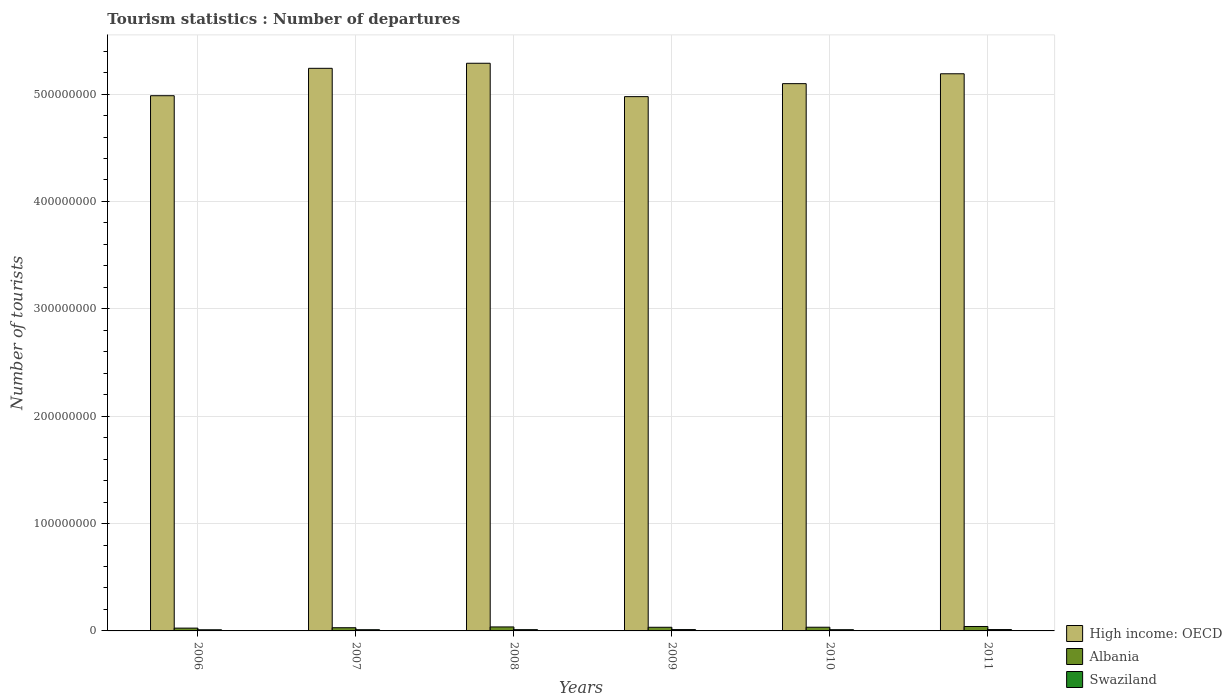Are the number of bars per tick equal to the number of legend labels?
Offer a very short reply. Yes. How many bars are there on the 3rd tick from the left?
Provide a succinct answer. 3. How many bars are there on the 2nd tick from the right?
Provide a short and direct response. 3. What is the number of tourist departures in Albania in 2011?
Ensure brevity in your answer.  4.12e+06. Across all years, what is the maximum number of tourist departures in Swaziland?
Provide a succinct answer. 1.26e+06. Across all years, what is the minimum number of tourist departures in Swaziland?
Offer a very short reply. 1.07e+06. In which year was the number of tourist departures in High income: OECD maximum?
Ensure brevity in your answer.  2008. What is the total number of tourist departures in Albania in the graph?
Give a very brief answer. 2.03e+07. What is the difference between the number of tourist departures in Swaziland in 2009 and that in 2011?
Offer a very short reply. -1.90e+04. What is the difference between the number of tourist departures in High income: OECD in 2007 and the number of tourist departures in Swaziland in 2010?
Your answer should be very brief. 5.23e+08. What is the average number of tourist departures in Albania per year?
Provide a succinct answer. 3.38e+06. In the year 2011, what is the difference between the number of tourist departures in Swaziland and number of tourist departures in Albania?
Offer a very short reply. -2.86e+06. What is the ratio of the number of tourist departures in High income: OECD in 2008 to that in 2010?
Your answer should be very brief. 1.04. Is the number of tourist departures in High income: OECD in 2009 less than that in 2010?
Ensure brevity in your answer.  Yes. Is the difference between the number of tourist departures in Swaziland in 2007 and 2009 greater than the difference between the number of tourist departures in Albania in 2007 and 2009?
Your response must be concise. Yes. What is the difference between the highest and the second highest number of tourist departures in Swaziland?
Offer a terse response. 1.90e+04. What is the difference between the highest and the lowest number of tourist departures in Swaziland?
Offer a very short reply. 1.92e+05. In how many years, is the number of tourist departures in High income: OECD greater than the average number of tourist departures in High income: OECD taken over all years?
Your answer should be compact. 3. Is the sum of the number of tourist departures in Albania in 2007 and 2010 greater than the maximum number of tourist departures in High income: OECD across all years?
Your answer should be compact. No. What does the 2nd bar from the left in 2006 represents?
Provide a short and direct response. Albania. What does the 2nd bar from the right in 2007 represents?
Your response must be concise. Albania. How many bars are there?
Offer a very short reply. 18. Are all the bars in the graph horizontal?
Make the answer very short. No. What is the difference between two consecutive major ticks on the Y-axis?
Provide a short and direct response. 1.00e+08. Does the graph contain any zero values?
Offer a very short reply. No. How many legend labels are there?
Ensure brevity in your answer.  3. How are the legend labels stacked?
Offer a terse response. Vertical. What is the title of the graph?
Provide a succinct answer. Tourism statistics : Number of departures. What is the label or title of the X-axis?
Make the answer very short. Years. What is the label or title of the Y-axis?
Your answer should be very brief. Number of tourists. What is the Number of tourists of High income: OECD in 2006?
Ensure brevity in your answer.  4.98e+08. What is the Number of tourists of Albania in 2006?
Your response must be concise. 2.62e+06. What is the Number of tourists of Swaziland in 2006?
Ensure brevity in your answer.  1.07e+06. What is the Number of tourists in High income: OECD in 2007?
Offer a terse response. 5.24e+08. What is the Number of tourists in Albania in 2007?
Make the answer very short. 2.98e+06. What is the Number of tourists in Swaziland in 2007?
Your answer should be compact. 1.13e+06. What is the Number of tourists in High income: OECD in 2008?
Offer a very short reply. 5.29e+08. What is the Number of tourists in Albania in 2008?
Ensure brevity in your answer.  3.72e+06. What is the Number of tourists in Swaziland in 2008?
Provide a succinct answer. 1.18e+06. What is the Number of tourists in High income: OECD in 2009?
Give a very brief answer. 4.98e+08. What is the Number of tourists of Albania in 2009?
Your answer should be compact. 3.40e+06. What is the Number of tourists of Swaziland in 2009?
Make the answer very short. 1.24e+06. What is the Number of tourists in High income: OECD in 2010?
Make the answer very short. 5.10e+08. What is the Number of tourists in Albania in 2010?
Give a very brief answer. 3.44e+06. What is the Number of tourists of Swaziland in 2010?
Your answer should be very brief. 1.14e+06. What is the Number of tourists in High income: OECD in 2011?
Your answer should be very brief. 5.19e+08. What is the Number of tourists in Albania in 2011?
Provide a short and direct response. 4.12e+06. What is the Number of tourists in Swaziland in 2011?
Offer a terse response. 1.26e+06. Across all years, what is the maximum Number of tourists in High income: OECD?
Make the answer very short. 5.29e+08. Across all years, what is the maximum Number of tourists in Albania?
Your answer should be compact. 4.12e+06. Across all years, what is the maximum Number of tourists in Swaziland?
Provide a short and direct response. 1.26e+06. Across all years, what is the minimum Number of tourists of High income: OECD?
Offer a terse response. 4.98e+08. Across all years, what is the minimum Number of tourists in Albania?
Make the answer very short. 2.62e+06. Across all years, what is the minimum Number of tourists in Swaziland?
Offer a very short reply. 1.07e+06. What is the total Number of tourists in High income: OECD in the graph?
Make the answer very short. 3.08e+09. What is the total Number of tourists in Albania in the graph?
Ensure brevity in your answer.  2.03e+07. What is the total Number of tourists of Swaziland in the graph?
Provide a succinct answer. 7.03e+06. What is the difference between the Number of tourists of High income: OECD in 2006 and that in 2007?
Give a very brief answer. -2.55e+07. What is the difference between the Number of tourists in Albania in 2006 and that in 2007?
Your response must be concise. -3.63e+05. What is the difference between the Number of tourists in Swaziland in 2006 and that in 2007?
Give a very brief answer. -5.80e+04. What is the difference between the Number of tourists of High income: OECD in 2006 and that in 2008?
Your response must be concise. -3.02e+07. What is the difference between the Number of tourists in Albania in 2006 and that in 2008?
Offer a very short reply. -1.10e+06. What is the difference between the Number of tourists in Swaziland in 2006 and that in 2008?
Offer a terse response. -1.05e+05. What is the difference between the Number of tourists of High income: OECD in 2006 and that in 2009?
Offer a terse response. 8.58e+05. What is the difference between the Number of tourists in Albania in 2006 and that in 2009?
Provide a short and direct response. -7.88e+05. What is the difference between the Number of tourists of Swaziland in 2006 and that in 2009?
Provide a succinct answer. -1.73e+05. What is the difference between the Number of tourists of High income: OECD in 2006 and that in 2010?
Give a very brief answer. -1.12e+07. What is the difference between the Number of tourists of Albania in 2006 and that in 2010?
Offer a very short reply. -8.27e+05. What is the difference between the Number of tourists of Swaziland in 2006 and that in 2010?
Your answer should be very brief. -6.90e+04. What is the difference between the Number of tourists in High income: OECD in 2006 and that in 2011?
Offer a terse response. -2.04e+07. What is the difference between the Number of tourists in Albania in 2006 and that in 2011?
Your answer should be compact. -1.50e+06. What is the difference between the Number of tourists of Swaziland in 2006 and that in 2011?
Give a very brief answer. -1.92e+05. What is the difference between the Number of tourists in High income: OECD in 2007 and that in 2008?
Provide a succinct answer. -4.72e+06. What is the difference between the Number of tourists in Albania in 2007 and that in 2008?
Give a very brief answer. -7.37e+05. What is the difference between the Number of tourists of Swaziland in 2007 and that in 2008?
Your answer should be compact. -4.70e+04. What is the difference between the Number of tourists of High income: OECD in 2007 and that in 2009?
Your answer should be very brief. 2.64e+07. What is the difference between the Number of tourists in Albania in 2007 and that in 2009?
Provide a succinct answer. -4.25e+05. What is the difference between the Number of tourists of Swaziland in 2007 and that in 2009?
Provide a short and direct response. -1.15e+05. What is the difference between the Number of tourists of High income: OECD in 2007 and that in 2010?
Provide a succinct answer. 1.43e+07. What is the difference between the Number of tourists of Albania in 2007 and that in 2010?
Your response must be concise. -4.64e+05. What is the difference between the Number of tourists of Swaziland in 2007 and that in 2010?
Your answer should be very brief. -1.10e+04. What is the difference between the Number of tourists in High income: OECD in 2007 and that in 2011?
Make the answer very short. 5.07e+06. What is the difference between the Number of tourists of Albania in 2007 and that in 2011?
Keep it short and to the point. -1.14e+06. What is the difference between the Number of tourists of Swaziland in 2007 and that in 2011?
Your answer should be very brief. -1.34e+05. What is the difference between the Number of tourists of High income: OECD in 2008 and that in 2009?
Your answer should be very brief. 3.11e+07. What is the difference between the Number of tourists of Albania in 2008 and that in 2009?
Keep it short and to the point. 3.12e+05. What is the difference between the Number of tourists in Swaziland in 2008 and that in 2009?
Make the answer very short. -6.80e+04. What is the difference between the Number of tourists in High income: OECD in 2008 and that in 2010?
Your answer should be very brief. 1.90e+07. What is the difference between the Number of tourists in Albania in 2008 and that in 2010?
Keep it short and to the point. 2.73e+05. What is the difference between the Number of tourists of Swaziland in 2008 and that in 2010?
Give a very brief answer. 3.60e+04. What is the difference between the Number of tourists in High income: OECD in 2008 and that in 2011?
Ensure brevity in your answer.  9.79e+06. What is the difference between the Number of tourists of Albania in 2008 and that in 2011?
Make the answer very short. -4.04e+05. What is the difference between the Number of tourists in Swaziland in 2008 and that in 2011?
Offer a very short reply. -8.70e+04. What is the difference between the Number of tourists in High income: OECD in 2009 and that in 2010?
Offer a very short reply. -1.21e+07. What is the difference between the Number of tourists of Albania in 2009 and that in 2010?
Provide a succinct answer. -3.90e+04. What is the difference between the Number of tourists in Swaziland in 2009 and that in 2010?
Offer a terse response. 1.04e+05. What is the difference between the Number of tourists of High income: OECD in 2009 and that in 2011?
Provide a succinct answer. -2.13e+07. What is the difference between the Number of tourists in Albania in 2009 and that in 2011?
Offer a terse response. -7.16e+05. What is the difference between the Number of tourists in Swaziland in 2009 and that in 2011?
Keep it short and to the point. -1.90e+04. What is the difference between the Number of tourists of High income: OECD in 2010 and that in 2011?
Give a very brief answer. -9.20e+06. What is the difference between the Number of tourists in Albania in 2010 and that in 2011?
Make the answer very short. -6.77e+05. What is the difference between the Number of tourists in Swaziland in 2010 and that in 2011?
Your answer should be very brief. -1.23e+05. What is the difference between the Number of tourists of High income: OECD in 2006 and the Number of tourists of Albania in 2007?
Provide a succinct answer. 4.95e+08. What is the difference between the Number of tourists of High income: OECD in 2006 and the Number of tourists of Swaziland in 2007?
Ensure brevity in your answer.  4.97e+08. What is the difference between the Number of tourists of Albania in 2006 and the Number of tourists of Swaziland in 2007?
Ensure brevity in your answer.  1.49e+06. What is the difference between the Number of tourists in High income: OECD in 2006 and the Number of tourists in Albania in 2008?
Make the answer very short. 4.95e+08. What is the difference between the Number of tourists of High income: OECD in 2006 and the Number of tourists of Swaziland in 2008?
Make the answer very short. 4.97e+08. What is the difference between the Number of tourists of Albania in 2006 and the Number of tourists of Swaziland in 2008?
Provide a succinct answer. 1.44e+06. What is the difference between the Number of tourists in High income: OECD in 2006 and the Number of tourists in Albania in 2009?
Provide a succinct answer. 4.95e+08. What is the difference between the Number of tourists in High income: OECD in 2006 and the Number of tourists in Swaziland in 2009?
Give a very brief answer. 4.97e+08. What is the difference between the Number of tourists in Albania in 2006 and the Number of tourists in Swaziland in 2009?
Your answer should be very brief. 1.37e+06. What is the difference between the Number of tourists in High income: OECD in 2006 and the Number of tourists in Albania in 2010?
Give a very brief answer. 4.95e+08. What is the difference between the Number of tourists of High income: OECD in 2006 and the Number of tourists of Swaziland in 2010?
Ensure brevity in your answer.  4.97e+08. What is the difference between the Number of tourists in Albania in 2006 and the Number of tourists in Swaziland in 2010?
Keep it short and to the point. 1.48e+06. What is the difference between the Number of tourists of High income: OECD in 2006 and the Number of tourists of Albania in 2011?
Keep it short and to the point. 4.94e+08. What is the difference between the Number of tourists of High income: OECD in 2006 and the Number of tourists of Swaziland in 2011?
Ensure brevity in your answer.  4.97e+08. What is the difference between the Number of tourists of Albania in 2006 and the Number of tourists of Swaziland in 2011?
Keep it short and to the point. 1.35e+06. What is the difference between the Number of tourists in High income: OECD in 2007 and the Number of tourists in Albania in 2008?
Offer a very short reply. 5.20e+08. What is the difference between the Number of tourists of High income: OECD in 2007 and the Number of tourists of Swaziland in 2008?
Offer a terse response. 5.23e+08. What is the difference between the Number of tourists of Albania in 2007 and the Number of tourists of Swaziland in 2008?
Your answer should be very brief. 1.80e+06. What is the difference between the Number of tourists in High income: OECD in 2007 and the Number of tourists in Albania in 2009?
Make the answer very short. 5.21e+08. What is the difference between the Number of tourists of High income: OECD in 2007 and the Number of tourists of Swaziland in 2009?
Offer a terse response. 5.23e+08. What is the difference between the Number of tourists of Albania in 2007 and the Number of tourists of Swaziland in 2009?
Your answer should be very brief. 1.73e+06. What is the difference between the Number of tourists of High income: OECD in 2007 and the Number of tourists of Albania in 2010?
Ensure brevity in your answer.  5.21e+08. What is the difference between the Number of tourists of High income: OECD in 2007 and the Number of tourists of Swaziland in 2010?
Ensure brevity in your answer.  5.23e+08. What is the difference between the Number of tourists of Albania in 2007 and the Number of tourists of Swaziland in 2010?
Make the answer very short. 1.84e+06. What is the difference between the Number of tourists of High income: OECD in 2007 and the Number of tourists of Albania in 2011?
Provide a succinct answer. 5.20e+08. What is the difference between the Number of tourists in High income: OECD in 2007 and the Number of tourists in Swaziland in 2011?
Your response must be concise. 5.23e+08. What is the difference between the Number of tourists in Albania in 2007 and the Number of tourists in Swaziland in 2011?
Make the answer very short. 1.72e+06. What is the difference between the Number of tourists of High income: OECD in 2008 and the Number of tourists of Albania in 2009?
Offer a terse response. 5.25e+08. What is the difference between the Number of tourists of High income: OECD in 2008 and the Number of tourists of Swaziland in 2009?
Provide a short and direct response. 5.27e+08. What is the difference between the Number of tourists of Albania in 2008 and the Number of tourists of Swaziland in 2009?
Keep it short and to the point. 2.47e+06. What is the difference between the Number of tourists of High income: OECD in 2008 and the Number of tourists of Albania in 2010?
Ensure brevity in your answer.  5.25e+08. What is the difference between the Number of tourists in High income: OECD in 2008 and the Number of tourists in Swaziland in 2010?
Offer a terse response. 5.28e+08. What is the difference between the Number of tourists in Albania in 2008 and the Number of tourists in Swaziland in 2010?
Offer a very short reply. 2.58e+06. What is the difference between the Number of tourists in High income: OECD in 2008 and the Number of tourists in Albania in 2011?
Offer a very short reply. 5.25e+08. What is the difference between the Number of tourists of High income: OECD in 2008 and the Number of tourists of Swaziland in 2011?
Make the answer very short. 5.27e+08. What is the difference between the Number of tourists of Albania in 2008 and the Number of tourists of Swaziland in 2011?
Your answer should be compact. 2.45e+06. What is the difference between the Number of tourists of High income: OECD in 2009 and the Number of tourists of Albania in 2010?
Your answer should be very brief. 4.94e+08. What is the difference between the Number of tourists in High income: OECD in 2009 and the Number of tourists in Swaziland in 2010?
Provide a succinct answer. 4.96e+08. What is the difference between the Number of tourists of Albania in 2009 and the Number of tourists of Swaziland in 2010?
Your answer should be compact. 2.26e+06. What is the difference between the Number of tourists of High income: OECD in 2009 and the Number of tourists of Albania in 2011?
Offer a terse response. 4.93e+08. What is the difference between the Number of tourists of High income: OECD in 2009 and the Number of tourists of Swaziland in 2011?
Give a very brief answer. 4.96e+08. What is the difference between the Number of tourists in Albania in 2009 and the Number of tourists in Swaziland in 2011?
Ensure brevity in your answer.  2.14e+06. What is the difference between the Number of tourists in High income: OECD in 2010 and the Number of tourists in Albania in 2011?
Your answer should be compact. 5.06e+08. What is the difference between the Number of tourists in High income: OECD in 2010 and the Number of tourists in Swaziland in 2011?
Offer a terse response. 5.08e+08. What is the difference between the Number of tourists in Albania in 2010 and the Number of tourists in Swaziland in 2011?
Provide a succinct answer. 2.18e+06. What is the average Number of tourists in High income: OECD per year?
Provide a succinct answer. 5.13e+08. What is the average Number of tourists in Albania per year?
Your answer should be very brief. 3.38e+06. What is the average Number of tourists of Swaziland per year?
Your response must be concise. 1.17e+06. In the year 2006, what is the difference between the Number of tourists of High income: OECD and Number of tourists of Albania?
Provide a short and direct response. 4.96e+08. In the year 2006, what is the difference between the Number of tourists of High income: OECD and Number of tourists of Swaziland?
Make the answer very short. 4.97e+08. In the year 2006, what is the difference between the Number of tourists in Albania and Number of tourists in Swaziland?
Make the answer very short. 1.54e+06. In the year 2007, what is the difference between the Number of tourists of High income: OECD and Number of tourists of Albania?
Offer a terse response. 5.21e+08. In the year 2007, what is the difference between the Number of tourists of High income: OECD and Number of tourists of Swaziland?
Ensure brevity in your answer.  5.23e+08. In the year 2007, what is the difference between the Number of tourists of Albania and Number of tourists of Swaziland?
Make the answer very short. 1.85e+06. In the year 2008, what is the difference between the Number of tourists in High income: OECD and Number of tourists in Albania?
Make the answer very short. 5.25e+08. In the year 2008, what is the difference between the Number of tourists in High income: OECD and Number of tourists in Swaziland?
Your response must be concise. 5.28e+08. In the year 2008, what is the difference between the Number of tourists in Albania and Number of tourists in Swaziland?
Keep it short and to the point. 2.54e+06. In the year 2009, what is the difference between the Number of tourists of High income: OECD and Number of tourists of Albania?
Provide a succinct answer. 4.94e+08. In the year 2009, what is the difference between the Number of tourists of High income: OECD and Number of tourists of Swaziland?
Give a very brief answer. 4.96e+08. In the year 2009, what is the difference between the Number of tourists in Albania and Number of tourists in Swaziland?
Keep it short and to the point. 2.16e+06. In the year 2010, what is the difference between the Number of tourists in High income: OECD and Number of tourists in Albania?
Make the answer very short. 5.06e+08. In the year 2010, what is the difference between the Number of tourists in High income: OECD and Number of tourists in Swaziland?
Ensure brevity in your answer.  5.09e+08. In the year 2010, what is the difference between the Number of tourists in Albania and Number of tourists in Swaziland?
Ensure brevity in your answer.  2.30e+06. In the year 2011, what is the difference between the Number of tourists in High income: OECD and Number of tourists in Albania?
Offer a very short reply. 5.15e+08. In the year 2011, what is the difference between the Number of tourists of High income: OECD and Number of tourists of Swaziland?
Provide a short and direct response. 5.18e+08. In the year 2011, what is the difference between the Number of tourists in Albania and Number of tourists in Swaziland?
Your response must be concise. 2.86e+06. What is the ratio of the Number of tourists in High income: OECD in 2006 to that in 2007?
Your answer should be very brief. 0.95. What is the ratio of the Number of tourists of Albania in 2006 to that in 2007?
Offer a very short reply. 0.88. What is the ratio of the Number of tourists in Swaziland in 2006 to that in 2007?
Your response must be concise. 0.95. What is the ratio of the Number of tourists in High income: OECD in 2006 to that in 2008?
Keep it short and to the point. 0.94. What is the ratio of the Number of tourists of Albania in 2006 to that in 2008?
Keep it short and to the point. 0.7. What is the ratio of the Number of tourists in Swaziland in 2006 to that in 2008?
Ensure brevity in your answer.  0.91. What is the ratio of the Number of tourists in High income: OECD in 2006 to that in 2009?
Your response must be concise. 1. What is the ratio of the Number of tourists in Albania in 2006 to that in 2009?
Your answer should be very brief. 0.77. What is the ratio of the Number of tourists of Swaziland in 2006 to that in 2009?
Provide a succinct answer. 0.86. What is the ratio of the Number of tourists in Albania in 2006 to that in 2010?
Provide a succinct answer. 0.76. What is the ratio of the Number of tourists of Swaziland in 2006 to that in 2010?
Keep it short and to the point. 0.94. What is the ratio of the Number of tourists in High income: OECD in 2006 to that in 2011?
Offer a terse response. 0.96. What is the ratio of the Number of tourists of Albania in 2006 to that in 2011?
Offer a very short reply. 0.64. What is the ratio of the Number of tourists of Swaziland in 2006 to that in 2011?
Give a very brief answer. 0.85. What is the ratio of the Number of tourists of High income: OECD in 2007 to that in 2008?
Give a very brief answer. 0.99. What is the ratio of the Number of tourists of Albania in 2007 to that in 2008?
Offer a terse response. 0.8. What is the ratio of the Number of tourists in Swaziland in 2007 to that in 2008?
Your response must be concise. 0.96. What is the ratio of the Number of tourists of High income: OECD in 2007 to that in 2009?
Provide a succinct answer. 1.05. What is the ratio of the Number of tourists of Albania in 2007 to that in 2009?
Provide a succinct answer. 0.88. What is the ratio of the Number of tourists of Swaziland in 2007 to that in 2009?
Your answer should be very brief. 0.91. What is the ratio of the Number of tourists of High income: OECD in 2007 to that in 2010?
Provide a short and direct response. 1.03. What is the ratio of the Number of tourists in Albania in 2007 to that in 2010?
Offer a very short reply. 0.87. What is the ratio of the Number of tourists in High income: OECD in 2007 to that in 2011?
Your response must be concise. 1.01. What is the ratio of the Number of tourists of Albania in 2007 to that in 2011?
Offer a terse response. 0.72. What is the ratio of the Number of tourists of Swaziland in 2007 to that in 2011?
Make the answer very short. 0.89. What is the ratio of the Number of tourists of High income: OECD in 2008 to that in 2009?
Keep it short and to the point. 1.06. What is the ratio of the Number of tourists of Albania in 2008 to that in 2009?
Your answer should be very brief. 1.09. What is the ratio of the Number of tourists of Swaziland in 2008 to that in 2009?
Keep it short and to the point. 0.95. What is the ratio of the Number of tourists of High income: OECD in 2008 to that in 2010?
Offer a very short reply. 1.04. What is the ratio of the Number of tourists in Albania in 2008 to that in 2010?
Your answer should be compact. 1.08. What is the ratio of the Number of tourists in Swaziland in 2008 to that in 2010?
Provide a succinct answer. 1.03. What is the ratio of the Number of tourists of High income: OECD in 2008 to that in 2011?
Ensure brevity in your answer.  1.02. What is the ratio of the Number of tourists in Albania in 2008 to that in 2011?
Your answer should be very brief. 0.9. What is the ratio of the Number of tourists of Swaziland in 2008 to that in 2011?
Provide a succinct answer. 0.93. What is the ratio of the Number of tourists of High income: OECD in 2009 to that in 2010?
Your answer should be very brief. 0.98. What is the ratio of the Number of tourists in Albania in 2009 to that in 2010?
Ensure brevity in your answer.  0.99. What is the ratio of the Number of tourists in Swaziland in 2009 to that in 2010?
Your response must be concise. 1.09. What is the ratio of the Number of tourists of High income: OECD in 2009 to that in 2011?
Your answer should be compact. 0.96. What is the ratio of the Number of tourists of Albania in 2009 to that in 2011?
Provide a short and direct response. 0.83. What is the ratio of the Number of tourists in High income: OECD in 2010 to that in 2011?
Offer a terse response. 0.98. What is the ratio of the Number of tourists in Albania in 2010 to that in 2011?
Give a very brief answer. 0.84. What is the ratio of the Number of tourists of Swaziland in 2010 to that in 2011?
Offer a terse response. 0.9. What is the difference between the highest and the second highest Number of tourists of High income: OECD?
Ensure brevity in your answer.  4.72e+06. What is the difference between the highest and the second highest Number of tourists in Albania?
Provide a short and direct response. 4.04e+05. What is the difference between the highest and the second highest Number of tourists in Swaziland?
Provide a succinct answer. 1.90e+04. What is the difference between the highest and the lowest Number of tourists in High income: OECD?
Provide a succinct answer. 3.11e+07. What is the difference between the highest and the lowest Number of tourists in Albania?
Offer a terse response. 1.50e+06. What is the difference between the highest and the lowest Number of tourists in Swaziland?
Your answer should be very brief. 1.92e+05. 